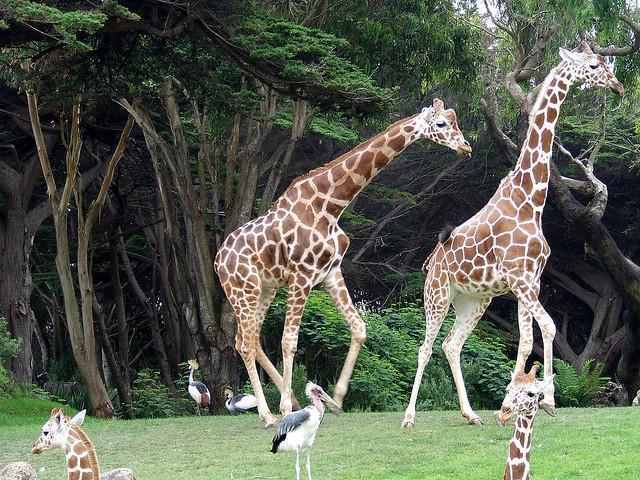How many giraffes?
Give a very brief answer. 4. How many giraffes are there?
Give a very brief answer. 4. 